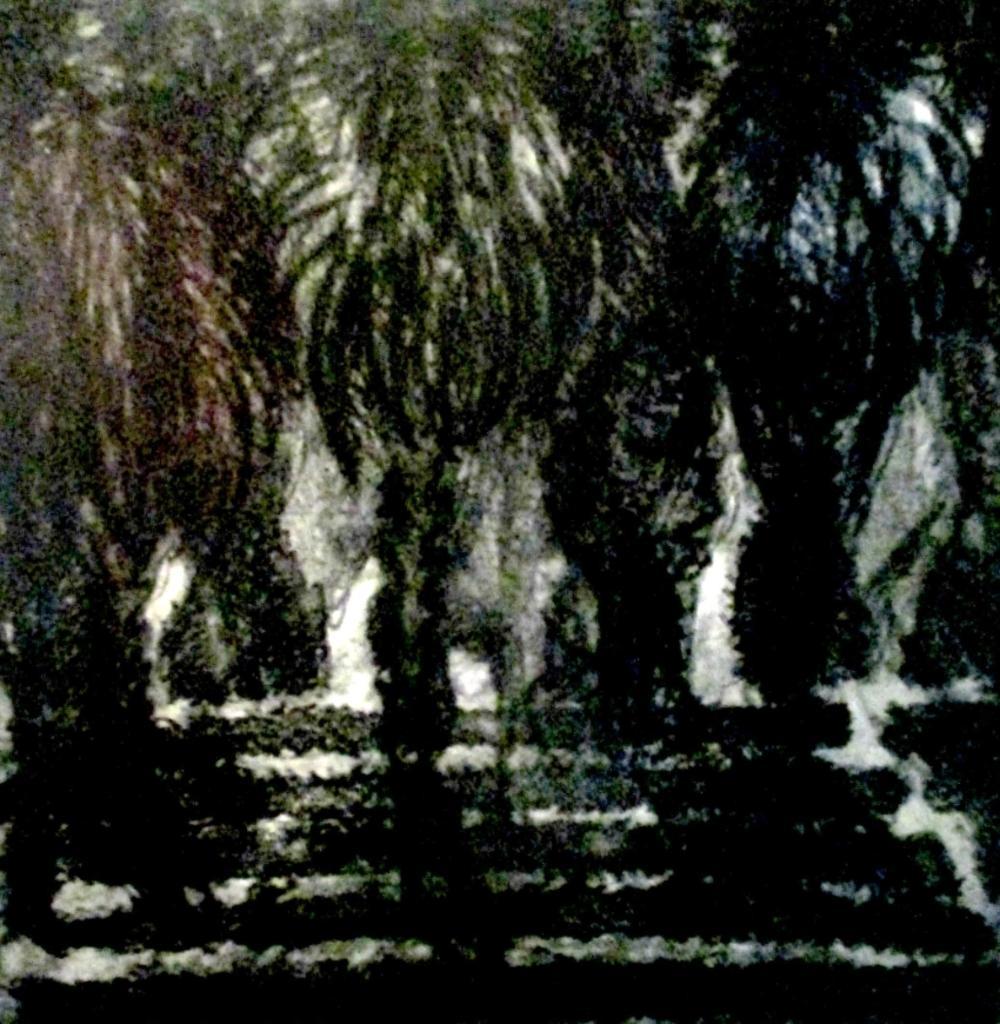Can you describe this image briefly? In this picture we can see some trees here. 